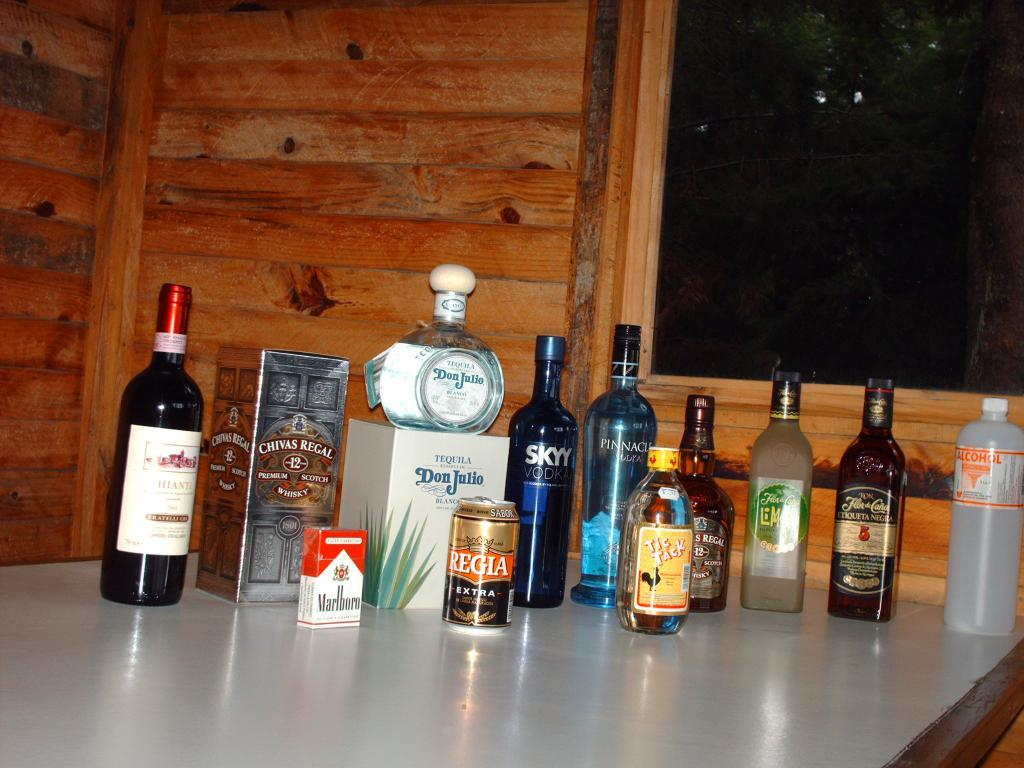<image>
Render a clear and concise summary of the photo. the word Don is on a white object 